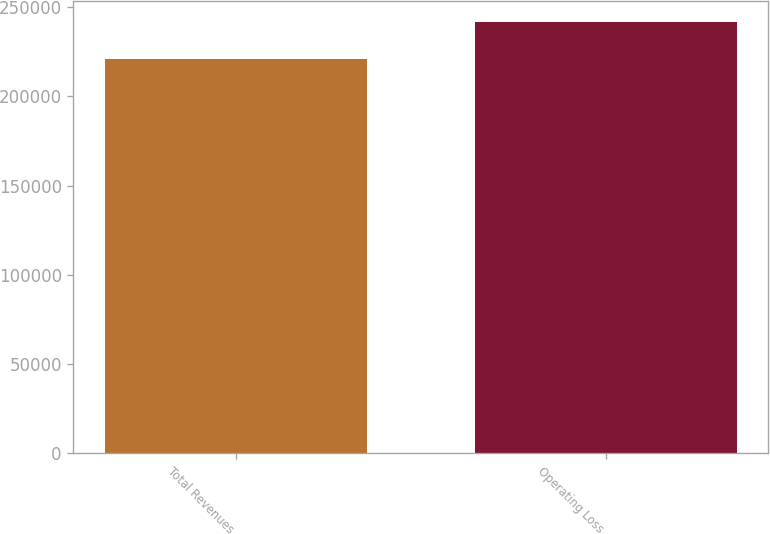<chart> <loc_0><loc_0><loc_500><loc_500><bar_chart><fcel>Total Revenues<fcel>Operating Loss<nl><fcel>221069<fcel>241450<nl></chart> 